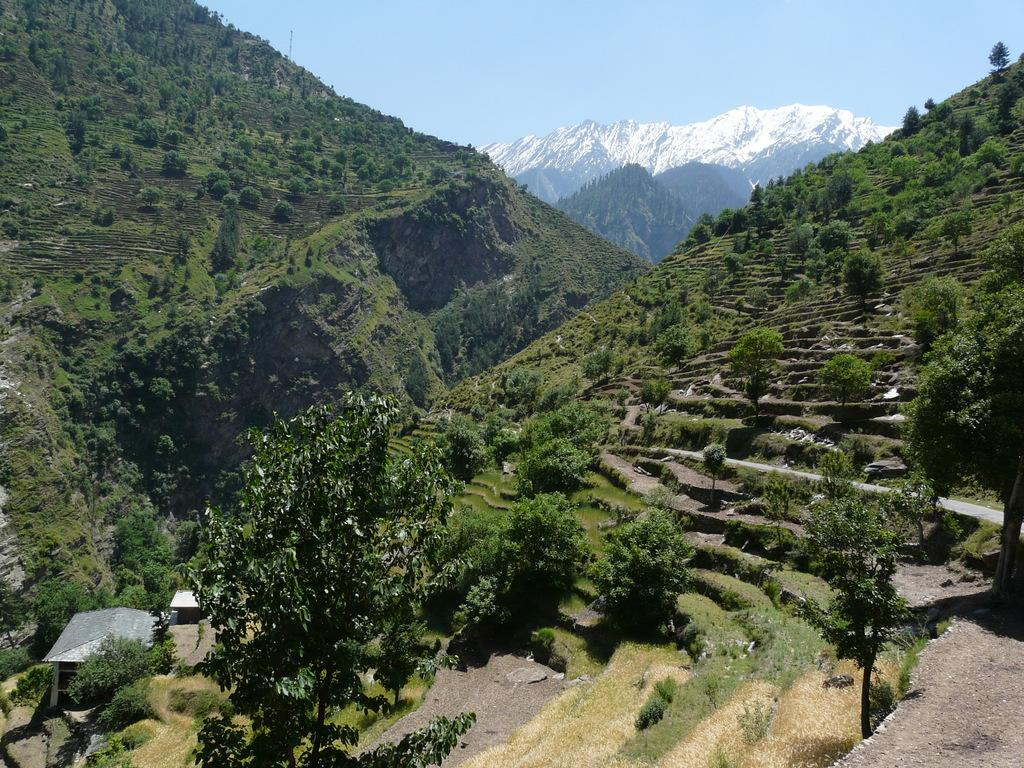What type of natural elements are present in the image? There are many trees and plants in the image. What structures can be seen to the left of the image? There are sheds to the left of the image. What type of landscape feature is visible in the background of the image? There are mountains visible in the background of the image. What else can be seen in the background of the image? The sky is visible in the background of the image. What type of juice is being served in the image? There is no juice present in the image; it features trees, plants, sheds, mountains, and the sky. Can you see any stockings hanging from the trees in the image? There are no stockings visible in the image; it features trees, plants, sheds, mountains, and the sky. 